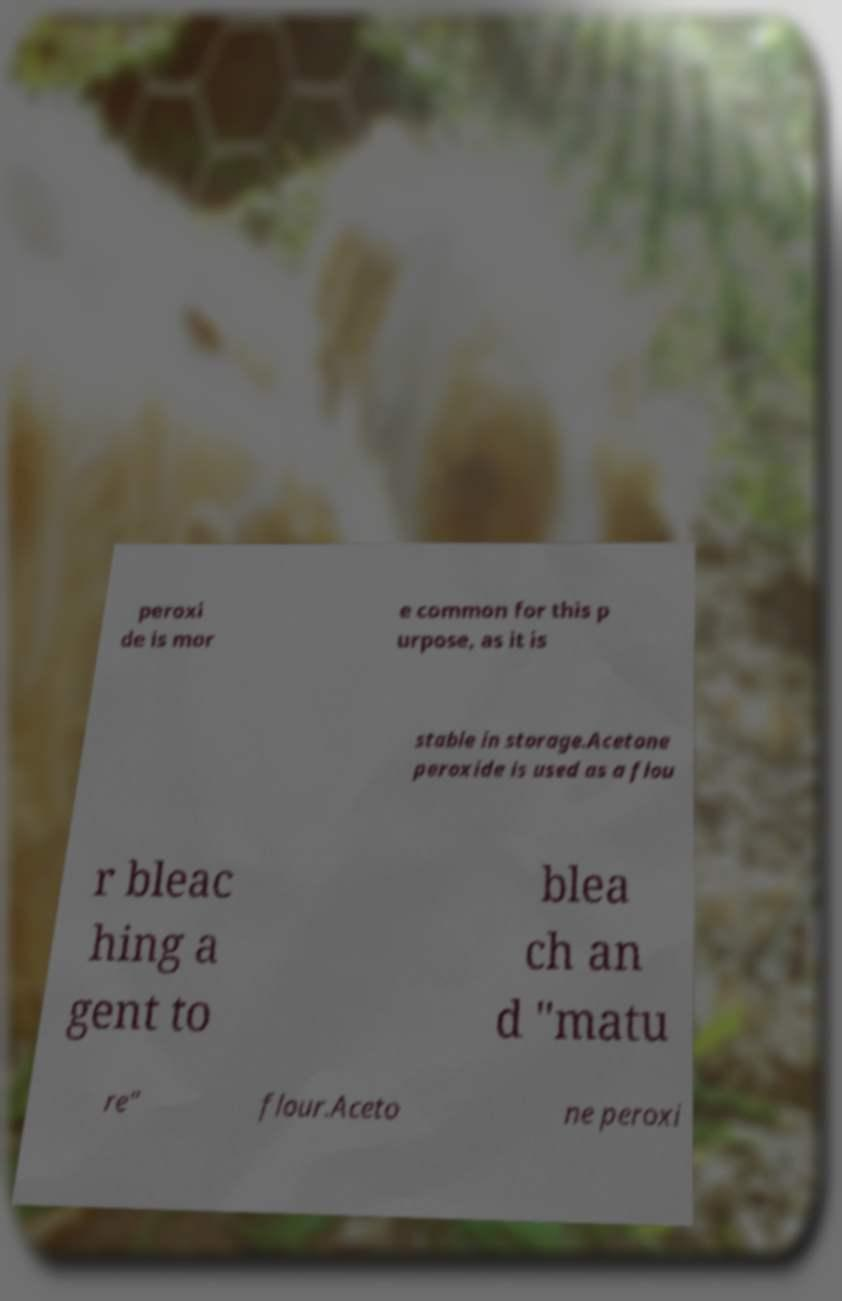For documentation purposes, I need the text within this image transcribed. Could you provide that? peroxi de is mor e common for this p urpose, as it is stable in storage.Acetone peroxide is used as a flou r bleac hing a gent to blea ch an d "matu re" flour.Aceto ne peroxi 